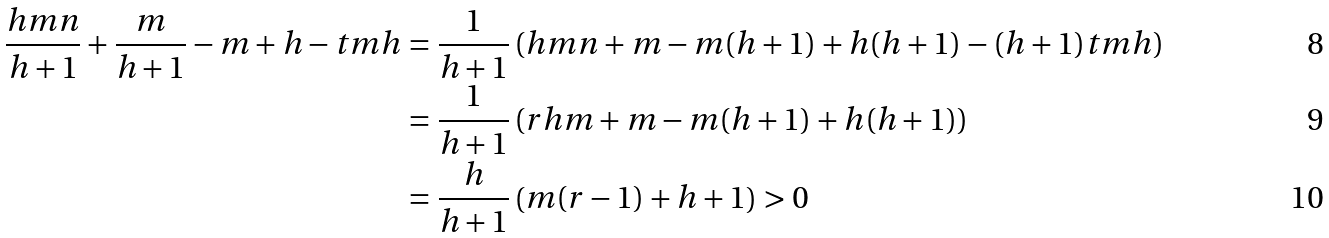<formula> <loc_0><loc_0><loc_500><loc_500>\frac { h m n } { h + 1 } + \frac { m } { h + 1 } - m + h - t m h & = \frac { 1 } { h + 1 } \left ( h m n + m - m ( h + 1 ) + h ( h + 1 ) - ( h + 1 ) t m h \right ) \\ & = \frac { 1 } { h + 1 } \left ( r h m + m - m ( h + 1 ) + h ( h + 1 ) \right ) \\ & = \frac { h } { h + 1 } \left ( m ( r - 1 ) + h + 1 \right ) > 0</formula> 